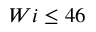Convert formula to latex. <formula><loc_0><loc_0><loc_500><loc_500>W i \leq 4 6</formula> 